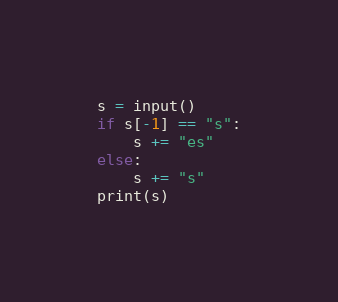<code> <loc_0><loc_0><loc_500><loc_500><_Python_>s = input()
if s[-1] == "s":
    s += "es"
else:
    s += "s"
print(s)</code> 